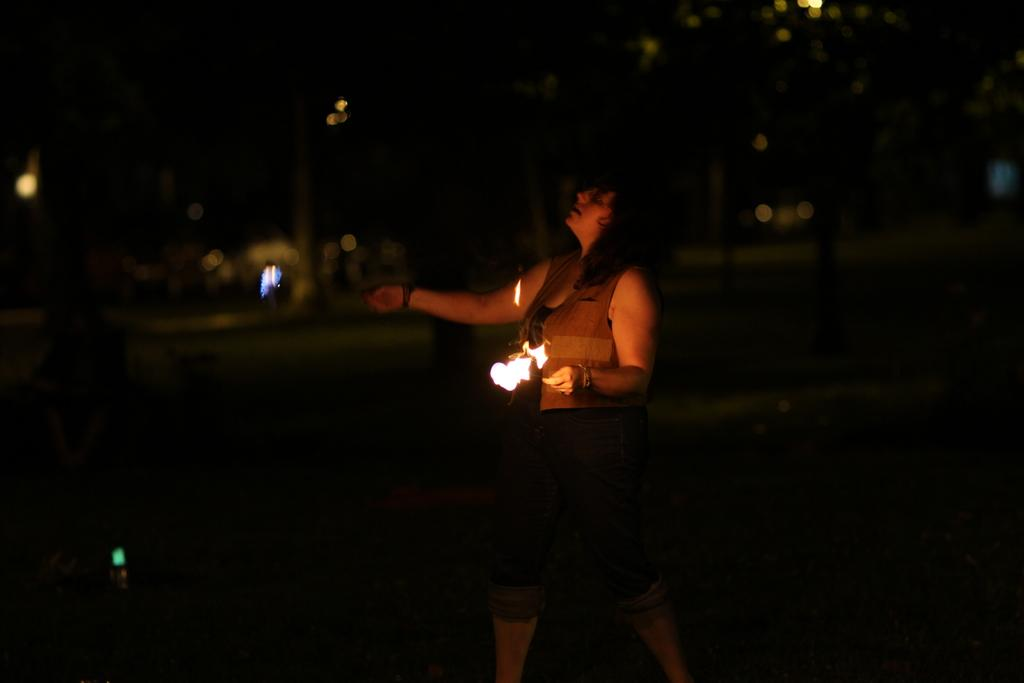What is the main subject of the image? There is a person in the image. What is the person doing in the image? The person is standing and playing with fire rods. What can be observed about the background of the image? The background of the image is dark. What type of bird can be seen flying in the image? There is no bird present in the image; it features a person playing with fire rods against a dark background. What kind of crack is visible on the ground in the image? There is no crack visible on the ground in the image; the person is standing and playing with fire rods against a dark background. 